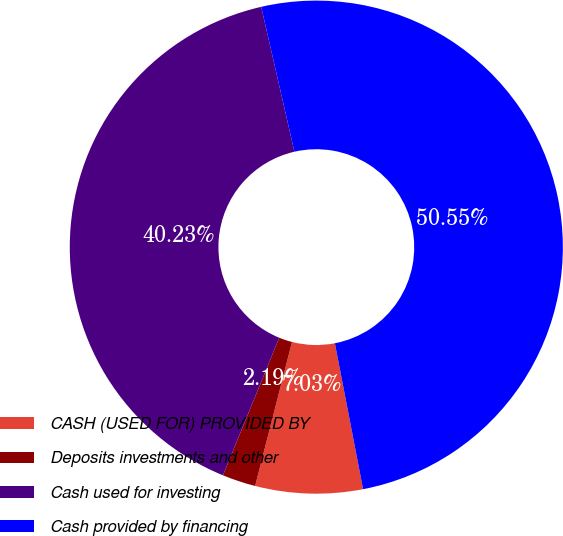<chart> <loc_0><loc_0><loc_500><loc_500><pie_chart><fcel>CASH (USED FOR) PROVIDED BY<fcel>Deposits investments and other<fcel>Cash used for investing<fcel>Cash provided by financing<nl><fcel>7.03%<fcel>2.19%<fcel>40.23%<fcel>50.55%<nl></chart> 